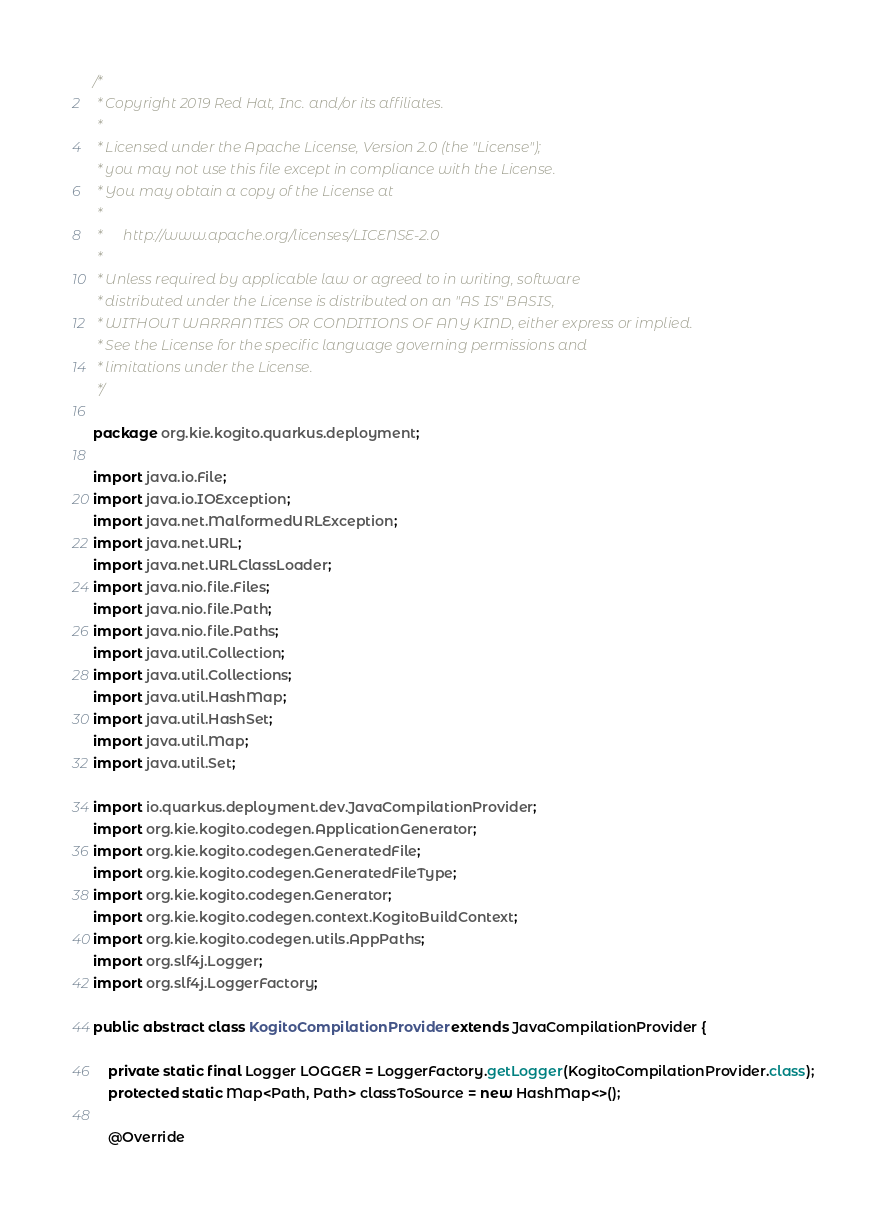<code> <loc_0><loc_0><loc_500><loc_500><_Java_>/*
 * Copyright 2019 Red Hat, Inc. and/or its affiliates.
 *
 * Licensed under the Apache License, Version 2.0 (the "License");
 * you may not use this file except in compliance with the License.
 * You may obtain a copy of the License at
 *
 *      http://www.apache.org/licenses/LICENSE-2.0
 *
 * Unless required by applicable law or agreed to in writing, software
 * distributed under the License is distributed on an "AS IS" BASIS,
 * WITHOUT WARRANTIES OR CONDITIONS OF ANY KIND, either express or implied.
 * See the License for the specific language governing permissions and
 * limitations under the License.
 */

package org.kie.kogito.quarkus.deployment;

import java.io.File;
import java.io.IOException;
import java.net.MalformedURLException;
import java.net.URL;
import java.net.URLClassLoader;
import java.nio.file.Files;
import java.nio.file.Path;
import java.nio.file.Paths;
import java.util.Collection;
import java.util.Collections;
import java.util.HashMap;
import java.util.HashSet;
import java.util.Map;
import java.util.Set;

import io.quarkus.deployment.dev.JavaCompilationProvider;
import org.kie.kogito.codegen.ApplicationGenerator;
import org.kie.kogito.codegen.GeneratedFile;
import org.kie.kogito.codegen.GeneratedFileType;
import org.kie.kogito.codegen.Generator;
import org.kie.kogito.codegen.context.KogitoBuildContext;
import org.kie.kogito.codegen.utils.AppPaths;
import org.slf4j.Logger;
import org.slf4j.LoggerFactory;

public abstract class KogitoCompilationProvider extends JavaCompilationProvider {

    private static final Logger LOGGER = LoggerFactory.getLogger(KogitoCompilationProvider.class);
    protected static Map<Path, Path> classToSource = new HashMap<>();

    @Override</code> 